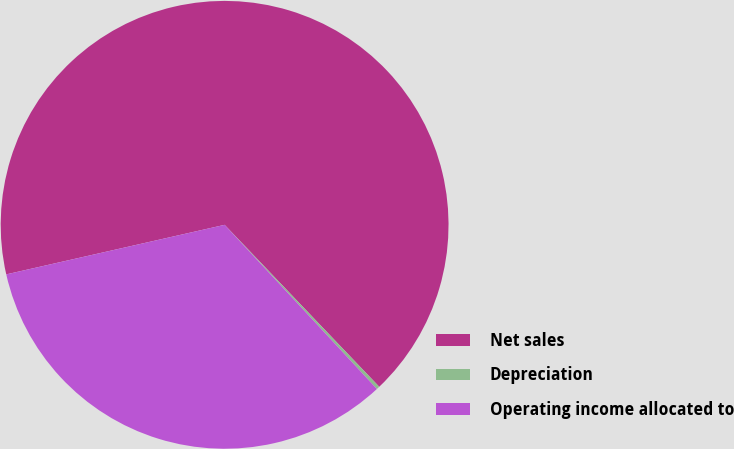Convert chart to OTSL. <chart><loc_0><loc_0><loc_500><loc_500><pie_chart><fcel>Net sales<fcel>Depreciation<fcel>Operating income allocated to<nl><fcel>66.42%<fcel>0.23%<fcel>33.35%<nl></chart> 